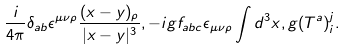<formula> <loc_0><loc_0><loc_500><loc_500>\frac { i } { 4 \pi } \delta _ { a b } \epsilon ^ { \mu \nu \rho } \frac { ( x - y ) _ { \rho } } { | x - y | ^ { 3 } } , - i g f _ { a b c } \epsilon _ { \mu \nu \rho } \int d ^ { 3 } x , g ( T ^ { a } ) _ { i } ^ { j } .</formula> 